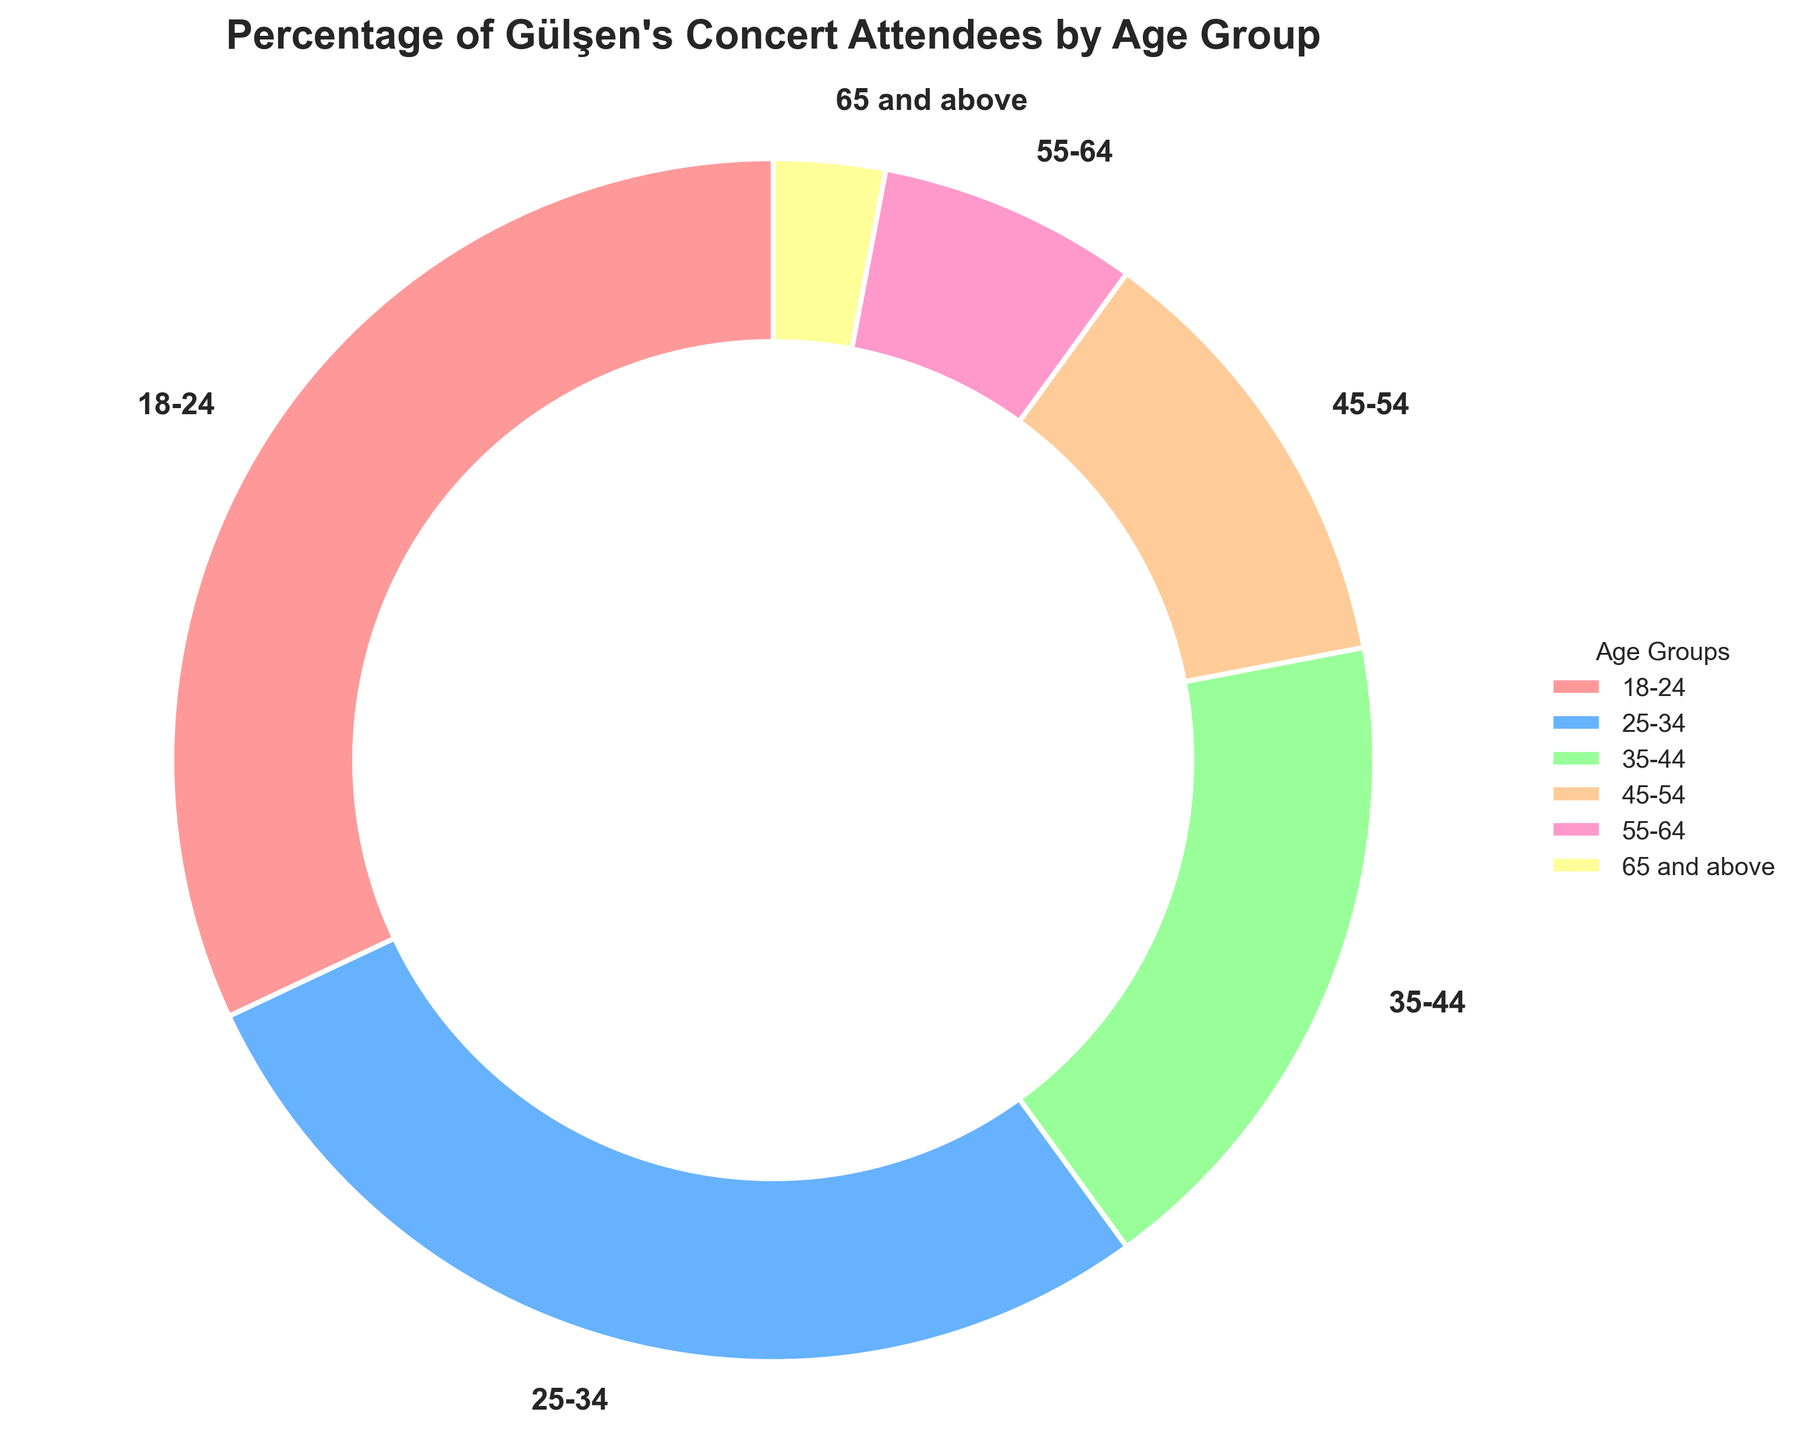What's the percentage of attendees aged 18-24? The pie chart shows that the 18-24 age group is represented by the largest slice, which is labeled with the corresponding percentage.
Answer: 32% Which age group has the smallest percentage of attendees? The smallest slice in the pie chart, indicated by its size and label, corresponds to the 65 and above age group.
Answer: 65 and above What is the combined percentage of attendees aged 35-44 and 45-54? The percentage for the 35-44 age group is 18%, and for the 45-54 age group, it is 12%. Adding these two percentages: 18% + 12% = 30%.
Answer: 30% How much larger is the percentage of the 18-24 age group compared to the 25-34 age group? The percentage for the 18-24 age group is 32%, and for the 25-34 age group, it is 28%. The difference between them is 32% - 28% = 4%.
Answer: 4% What age group has twice the percentage of the 55-64 age group? The 55-64 age group percentage is 7%. The 25-34 age group has a percentage of 28%, which is four times more than 7%, but there isn’t another group with exactly twice the percentage of 7%. The 18-24 group is closest with their percentage (32%) being a bit more than double.
Answer: 18-24 Which age groups combined make up more than 50% of the attendees? The 18-24 age group has 32%, and 25-34 has 28%. Combining these: 32% + 28% = 60%, which is more than 50%.
Answer: 18-24 and 25-34 If the percentages are converted to actual number of attendees where 1000 people attended the concert, how many attendees are in the 55-64 age group? The percentage for the 55-64 age group is 7%. With 1000 attendees, the number of attendees in this group is 7/100 * 1000 = 70.
Answer: 70 Which two age groups have the same combined percentage as the 18-24 age group alone? The 18-24 age group is 32%. The 35-44 group has 18% and the 45-54 group has 12%. Their combined percentage is 18% + 12% = 30%, which is close but less. The 25-34 group (28%) and the 65 and above group (3%) together have 28% + 3% = 31%, also less. Realistically, the other groups combined don't exactly add up to match the 18-24 group.
Answer: No exact match What’s the difference between the percentage of the group with most attendees and the group with the least? The group with most attendees (18-24) has 32%, and the group with the least (65 and above) has 3%. The difference between them is 32% - 3% = 29%.
Answer: 29% 